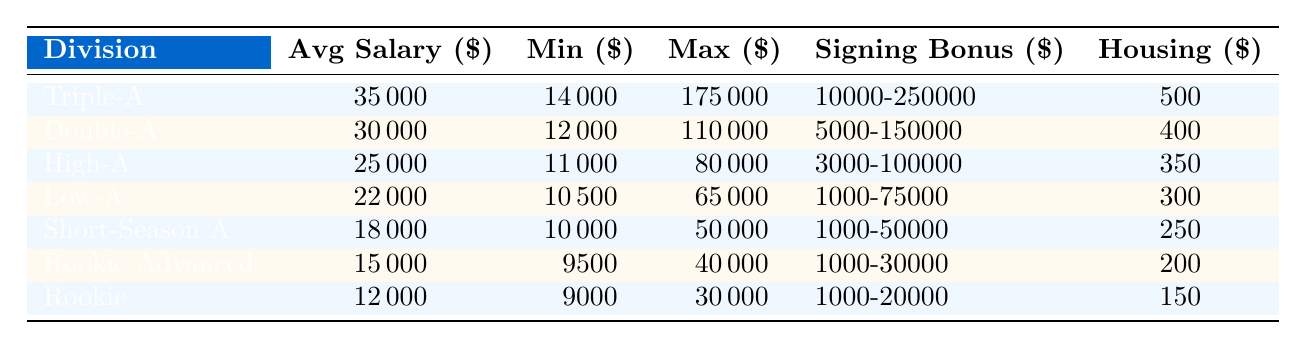What is the average annual salary for the Triple-A division? The table indicates that the average annual salary for Triple-A is listed under the "Average Annual Salary ($)" column next to "Triple-A." That value is 35,000.
Answer: 35000 What is the minimum salary in the Rookie division? Looking at the "Minimum Salary ($)" column next to the Rookie division, the minimum salary listed is 9,000.
Answer: 9000 Which minor league division has the highest maximum salary? By comparing the "Maximum Salary ($)" values across all divisions, the highest value of 175,000 corresponds to the Triple-A division.
Answer: Triple-A Is the average salary for Low-A higher than that for Rookie Advanced? The average salary for Low-A is 22,000, while that for Rookie Advanced is 15,000. Since 22,000 is greater than 15,000, the statement is true.
Answer: Yes What is the total range of signing bonuses available for High-A? The signing bonus range for High-A is listed as 3,000 to 100,000. To find the total range, we observe the values in the "Signing Bonus Range ($)" column for High-A, which means players can receive bonuses between 3,000 and 100,000.
Answer: 3000-100000 What is the difference in average annual salary between Triple-A and Rookie divisions? The average salary for Triple-A is 35,000 and for Rookie it is 12,000. The difference is calculated as 35,000 - 12,000 = 23,000.
Answer: 23000 How much lower is the maximum salary for Rookie compared to that for Short-Season A? The maximum salary for Rookie is 30,000 while for Short-Season A it is 50,000. The difference is 50,000 - 30,000 = 20,000.
Answer: 20000 Is the housing stipend for Double-A division fewer than 500 dollars? The housing stipend for Double-A is listed as 400 dollars, which is indeed fewer than 500 dollars.
Answer: Yes Which minor league division has the smallest average salary and what is that salary? By examining the "Average Annual Salary ($)" column, it is clear that the Rookie division has the smallest average salary, which is 12,000.
Answer: Rookie, 12000 If a player in Short-Season A receives a maximum signing bonus, what would that be? The signing bonus range for Short-Season A is 1,000 to 50,000. The maximum signing bonus is therefore 50,000.
Answer: 50000 